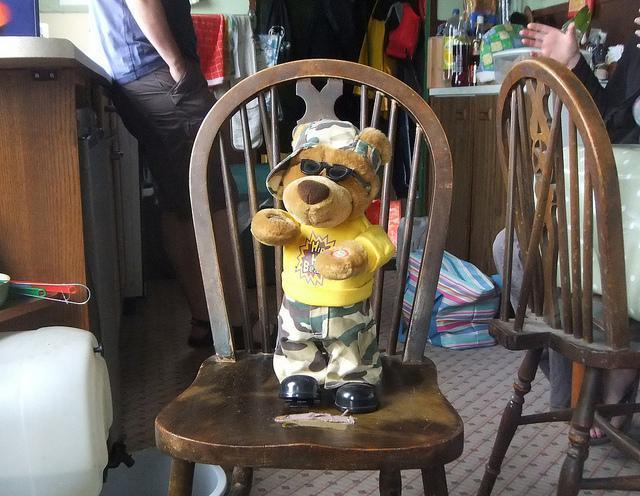How many fingers are visible on the combined two humans?
Give a very brief answer. 4. How many people are visible?
Give a very brief answer. 2. How many chairs are there?
Give a very brief answer. 2. 